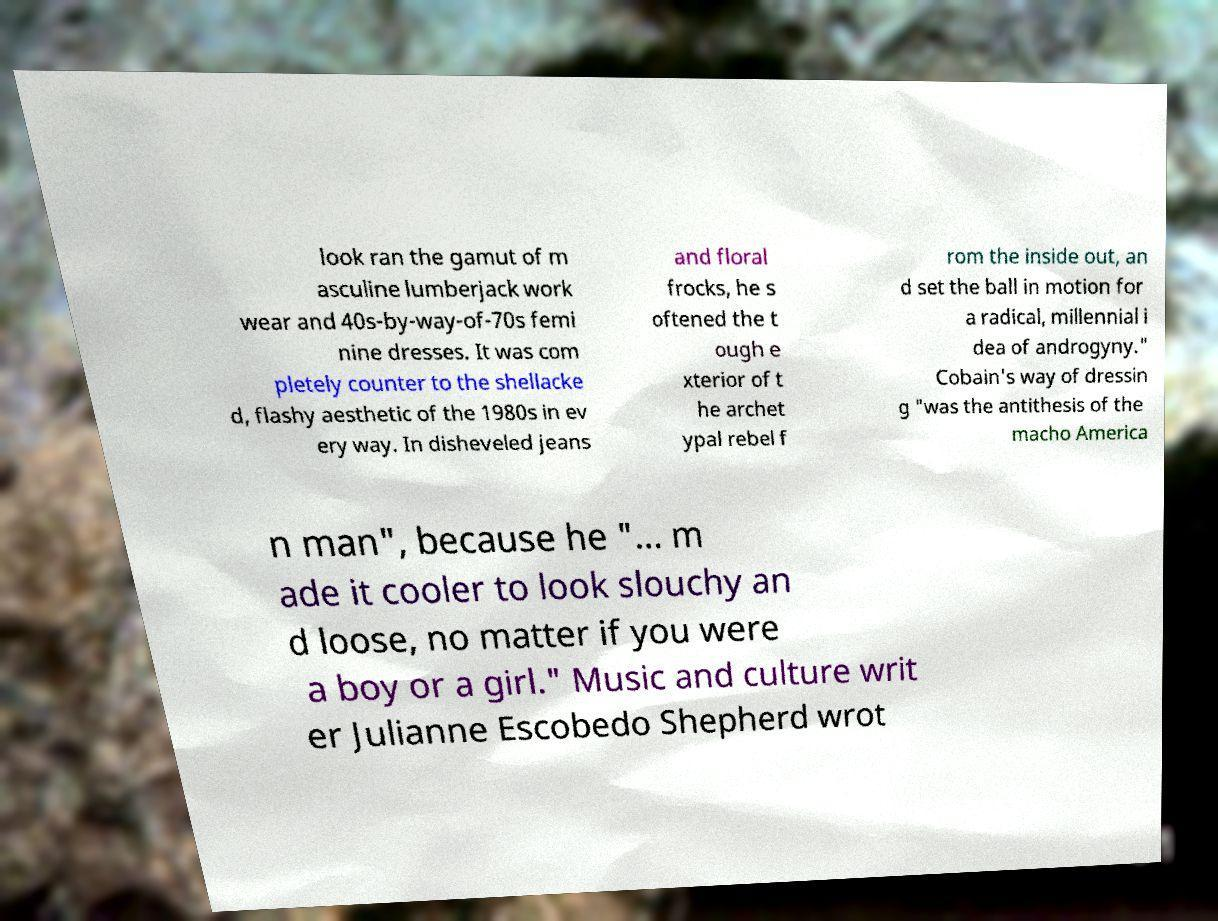What messages or text are displayed in this image? I need them in a readable, typed format. look ran the gamut of m asculine lumberjack work wear and 40s-by-way-of-70s femi nine dresses. It was com pletely counter to the shellacke d, flashy aesthetic of the 1980s in ev ery way. In disheveled jeans and floral frocks, he s oftened the t ough e xterior of t he archet ypal rebel f rom the inside out, an d set the ball in motion for a radical, millennial i dea of androgyny." Cobain's way of dressin g "was the antithesis of the macho America n man", because he "... m ade it cooler to look slouchy an d loose, no matter if you were a boy or a girl." Music and culture writ er Julianne Escobedo Shepherd wrot 